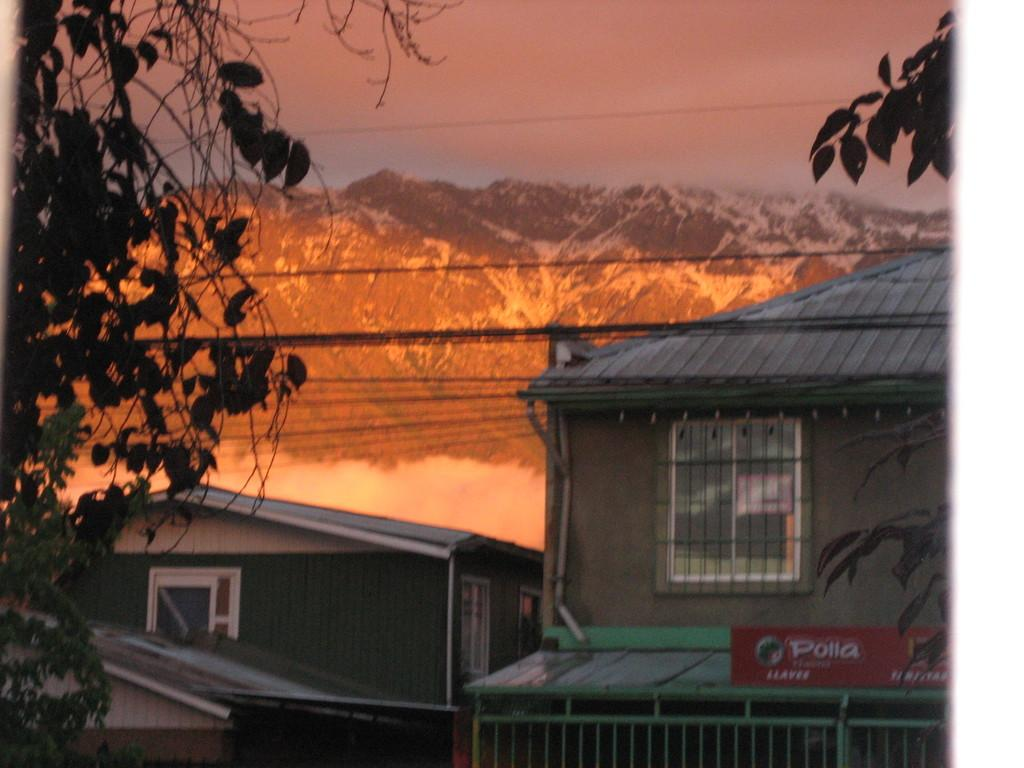What type of structures are located in the middle of the image? There are houses in the middle of the image. What natural feature can be seen in the background of the image? There are mountains in the background of the image. What type of vegetation is on the left side of the image? There are plants on the left side of the image. What is present at the top of the image? There are wires at the top of the image. Can you tell me how many times the person in the image sneezes? There is no person present in the image, so it is not possible to determine how many times they sneeze. What type of humor is depicted in the image? There is no humor depicted in the image; it features houses, mountains, plants, and wires. 